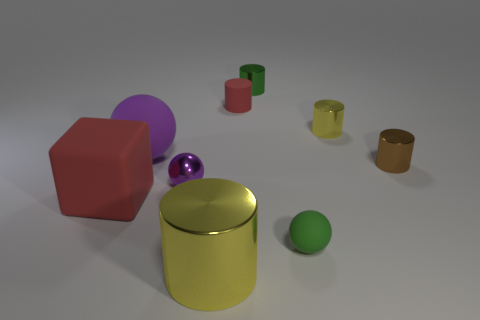Are there more tiny green objects that are in front of the brown metallic cylinder than small matte cylinders?
Give a very brief answer. No. What material is the ball that is to the right of the big purple rubber sphere and behind the big rubber cube?
Your response must be concise. Metal. Is there anything else that has the same shape as the big yellow metallic object?
Give a very brief answer. Yes. How many metal things are both in front of the small yellow cylinder and behind the large red rubber thing?
Offer a very short reply. 2. What is the material of the brown object?
Make the answer very short. Metal. Is the number of green cylinders that are behind the small purple thing the same as the number of small purple rubber cylinders?
Make the answer very short. No. How many other big objects are the same shape as the green metal thing?
Ensure brevity in your answer.  1. Is the big purple thing the same shape as the large shiny thing?
Provide a short and direct response. No. What number of things are balls behind the small purple metal ball or tiny yellow things?
Ensure brevity in your answer.  2. What shape is the small metal object behind the yellow metallic object that is behind the sphere behind the small brown metal object?
Your answer should be very brief. Cylinder. 